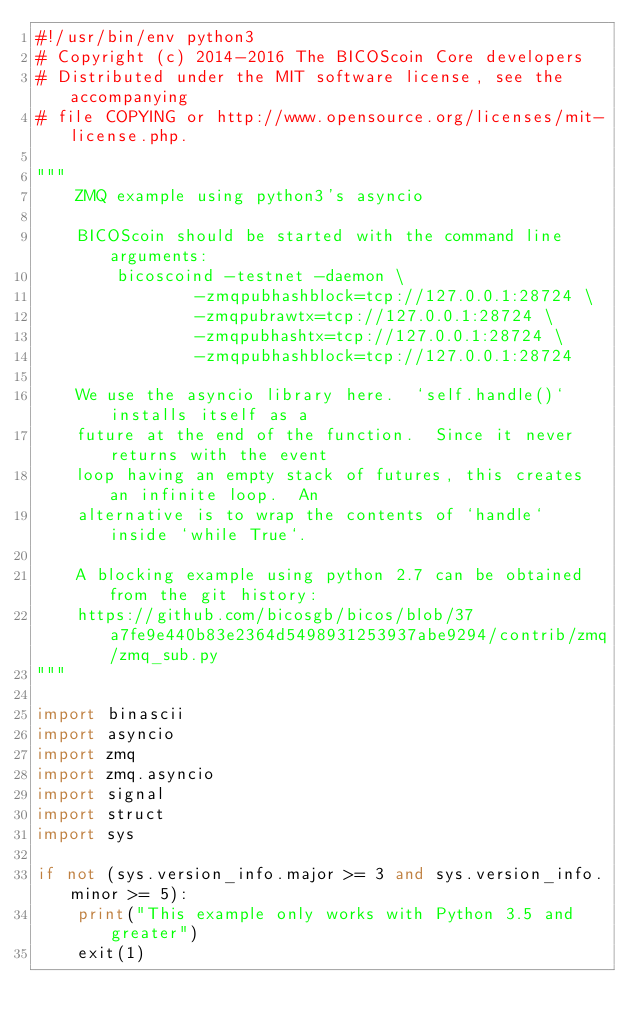<code> <loc_0><loc_0><loc_500><loc_500><_Python_>#!/usr/bin/env python3
# Copyright (c) 2014-2016 The BICOScoin Core developers
# Distributed under the MIT software license, see the accompanying
# file COPYING or http://www.opensource.org/licenses/mit-license.php.

"""
    ZMQ example using python3's asyncio

    BICOScoin should be started with the command line arguments:
        bicoscoind -testnet -daemon \
                -zmqpubhashblock=tcp://127.0.0.1:28724 \
                -zmqpubrawtx=tcp://127.0.0.1:28724 \
                -zmqpubhashtx=tcp://127.0.0.1:28724 \
                -zmqpubhashblock=tcp://127.0.0.1:28724

    We use the asyncio library here.  `self.handle()` installs itself as a
    future at the end of the function.  Since it never returns with the event
    loop having an empty stack of futures, this creates an infinite loop.  An
    alternative is to wrap the contents of `handle` inside `while True`.

    A blocking example using python 2.7 can be obtained from the git history:
    https://github.com/bicosgb/bicos/blob/37a7fe9e440b83e2364d5498931253937abe9294/contrib/zmq/zmq_sub.py
"""

import binascii
import asyncio
import zmq
import zmq.asyncio
import signal
import struct
import sys

if not (sys.version_info.major >= 3 and sys.version_info.minor >= 5):
    print("This example only works with Python 3.5 and greater")
    exit(1)
</code> 